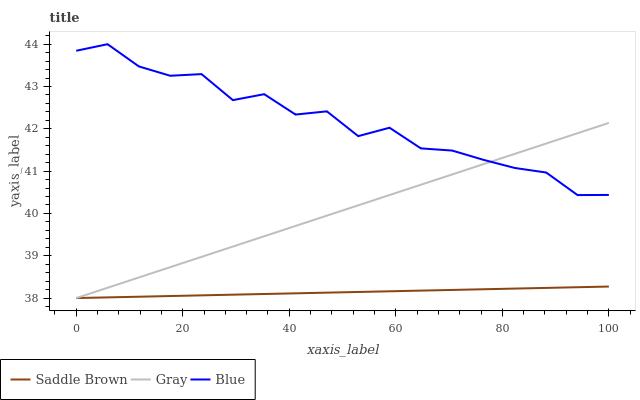Does Gray have the minimum area under the curve?
Answer yes or no. No. Does Gray have the maximum area under the curve?
Answer yes or no. No. Is Saddle Brown the smoothest?
Answer yes or no. No. Is Saddle Brown the roughest?
Answer yes or no. No. Does Gray have the highest value?
Answer yes or no. No. Is Saddle Brown less than Blue?
Answer yes or no. Yes. Is Blue greater than Saddle Brown?
Answer yes or no. Yes. Does Saddle Brown intersect Blue?
Answer yes or no. No. 